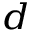<formula> <loc_0><loc_0><loc_500><loc_500>^ { d }</formula> 